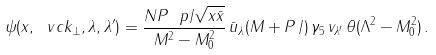<formula> <loc_0><loc_0><loc_500><loc_500>\psi ( x , \ v c { k } _ { \perp } , \lambda , \lambda ^ { \prime } ) = \frac { N P ^ { \ } p / \sqrt { x \bar { x } } } { M ^ { 2 } - M _ { 0 } ^ { 2 } } \, \bar { u } _ { \lambda } ( M + P \, / ) \, \gamma _ { 5 } \, v _ { \lambda ^ { \prime } } \, \theta ( \Lambda ^ { 2 } - M _ { 0 } ^ { 2 } ) \, .</formula> 